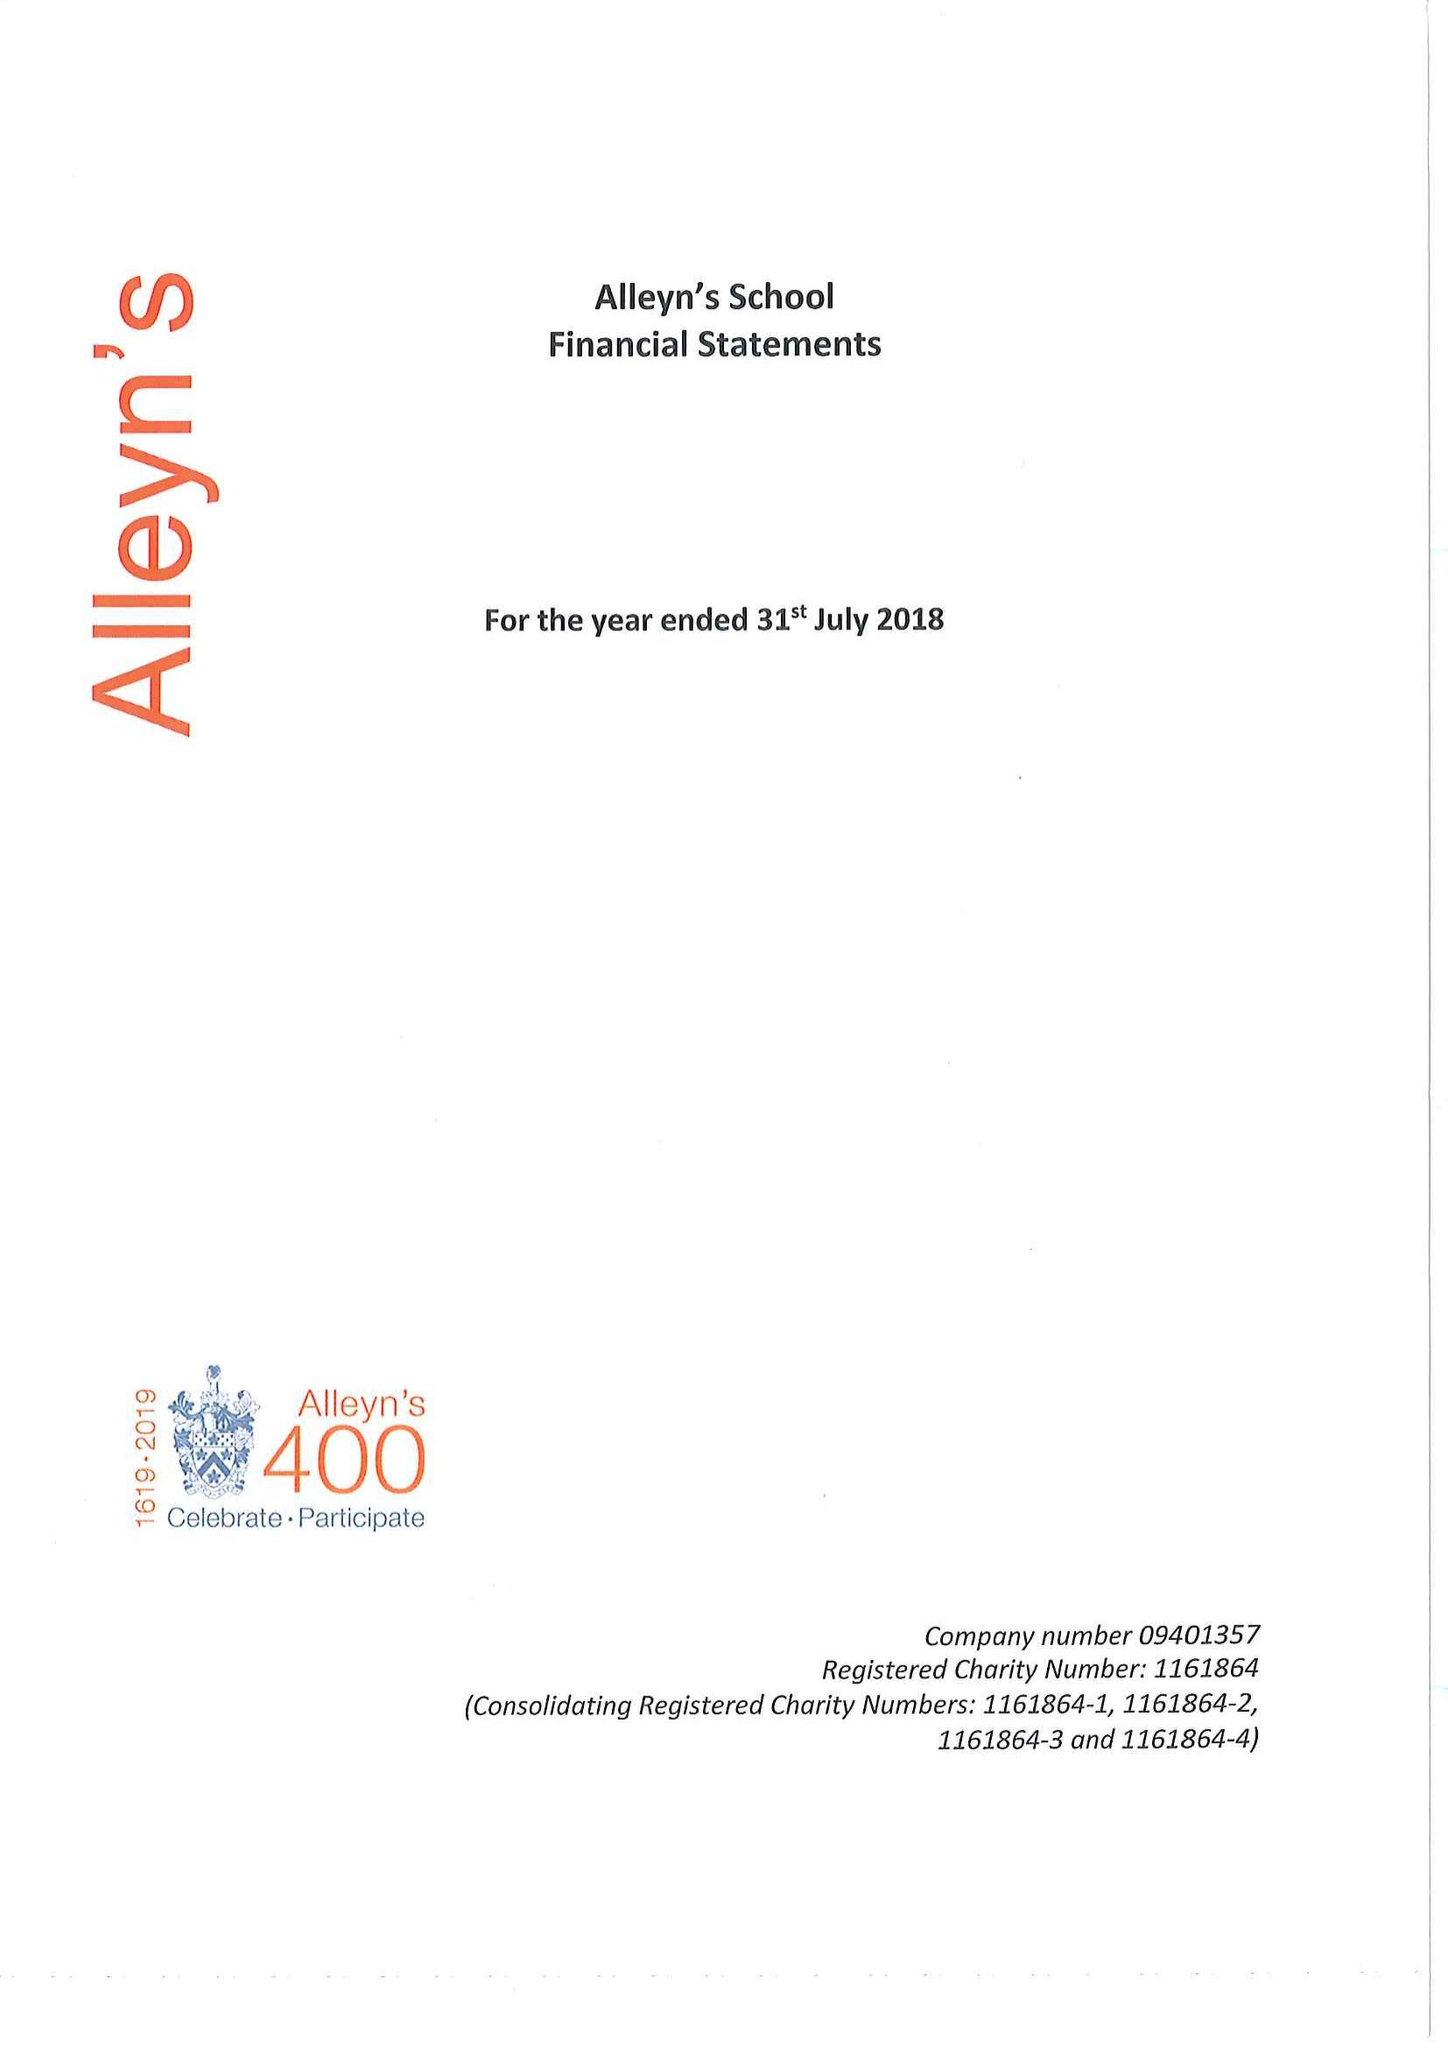What is the value for the address__post_town?
Answer the question using a single word or phrase. LONDON 